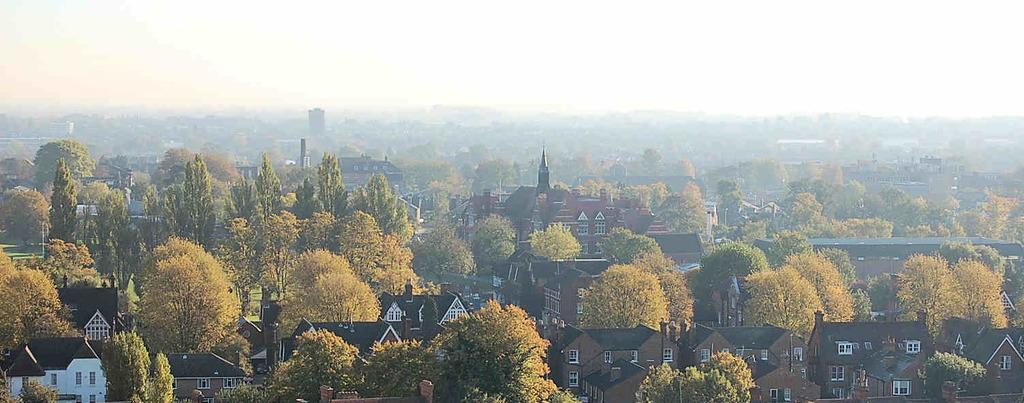What type of structures are visible in the image? There is a group of houses in the image. What features do the houses have? The houses have roofs and windows. What else can be seen in the image besides the houses? There is a group of trees in the image. What is visible in the background of the image? The sky is visible in the image, and it looks cloudy. Who is the owner of the jar in the image? There is no jar present in the image. What type of lamp can be seen illuminating the houses in the image? There is no lamp present in the image; the houses are illuminated by natural light from the sky. 